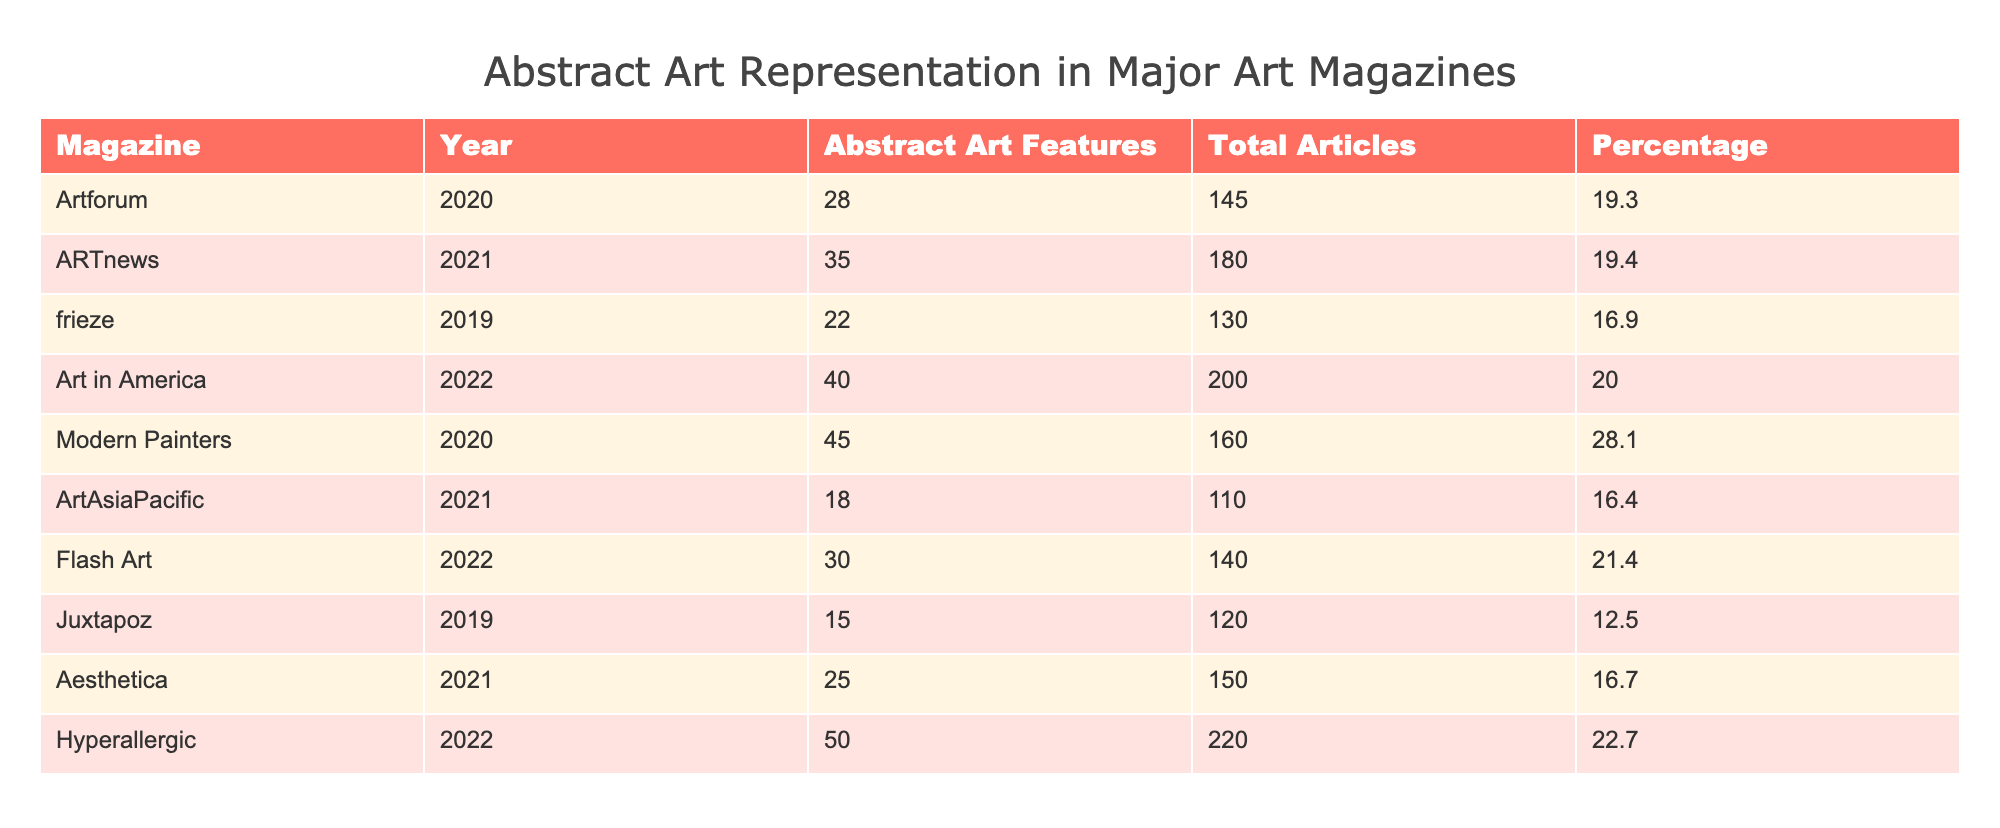What magazine had the highest percentage of abstract art features? Looking at the table, Modern Painters has a percentage of 28.1, which is the highest among the listed magazines.
Answer: Modern Painters What is the total number of abstract art features in Art in America? The table shows that Art in America has 40 abstract art features listed.
Answer: 40 How many magazines had more than 20 abstract art features? By counting the number of magazines in the table that list more than 20 features, we identify Artforum, ARTnews, Art in America, Modern Painters, Flash Art, and Hyperallergic, totaling six magazines.
Answer: 6 What is the average percentage of abstract art features across all magazines listed? To find the average percentage, sum all the percentages (19.3 + 19.4 + 16.9 + 20.0 + 28.1 + 16.4 + 21.4 + 12.5 + 16.7 + 22.7 =  154.4) and divide by the number of magazines (10). The calculation yields 154.4 / 10 = 15.44, which is 15.44%.
Answer: 15.44 Did Juxtapoz have a higher total number of articles than ArtAsiaPacific? By comparing the total articles, Juxtapoz has 120 and ArtAsiaPacific has 110. Therefore, Juxtapoz does have a higher total count.
Answer: Yes Which magazine published the most articles overall? Looking at the total articles column, Art in America published the most articles, with a total of 200.
Answer: Art in America What is the difference in abstract art features between the magazine with the most and the least? The magazine with the most features is Hyperallergic with 50, and the least is Juxtapoz with 15. The difference is 50 - 15 = 35.
Answer: 35 Which magazine's percentage of abstract art features is below 15%? The table reveals that only Juxtapoz with a percentage of 12.5% falls below this threshold.
Answer: Juxtapoz Is the representation of abstract art features in 2022 greater than in 2021? By examining the features from both years, 2022 has (40 + 30 + 50) totaling 120 features, while 2021 has (35 + 18 + 25) totaling 78 features. Since 120 is greater than 78, the representation is indeed greater in 2022.
Answer: Yes 